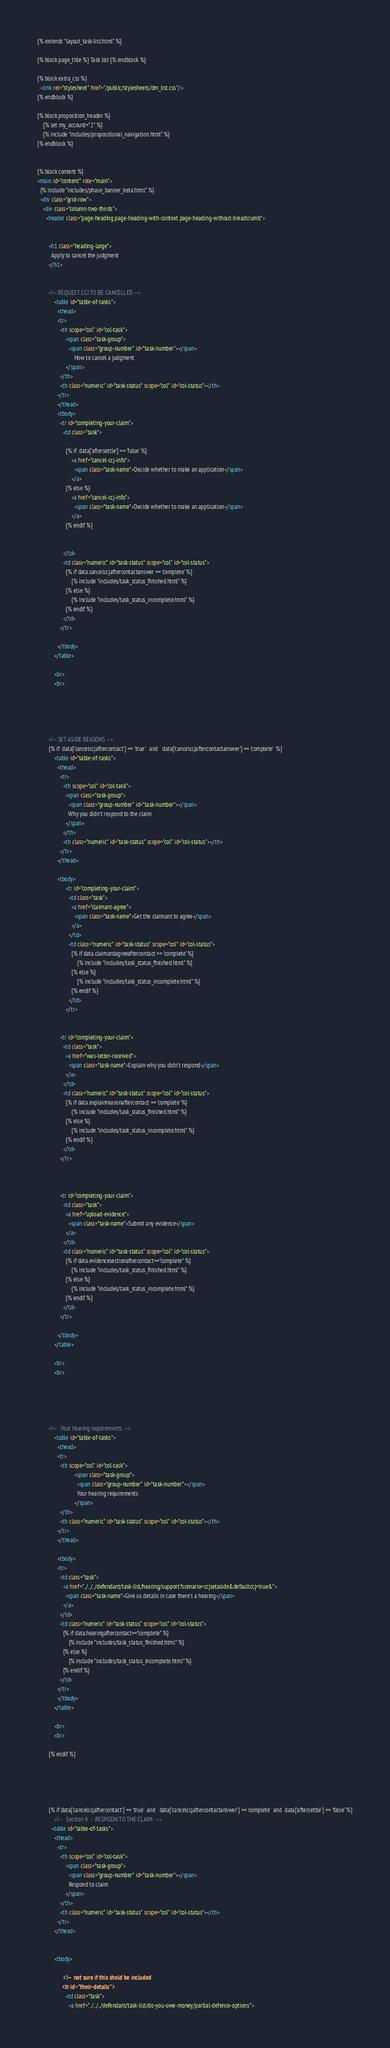Convert code to text. <code><loc_0><loc_0><loc_500><loc_500><_HTML_>{% extends "layout_task-list.html" %}

{% block page_title %} Task list {% endblock %}

{% block extra_css %}
  <link rel="stylesheet" href="/public/stylesheets/dm_list.css"/>
{% endblock %}

{% block proposition_header %}
    {% set my_account="2" %}
    {% include "includes/propositional_navigation.html" %}
{% endblock %}


{% block content %}
<main id="content" role="main">
  {% include "includes/phase_banner_beta.html" %}
  <div class="grid-row">
    <div class="column-two-thirds">
      <header class="page-heading page-heading-with-context page-heading-without-breadcrumb">


        <h1 class="heading-large">
          Apply to cancel the judgment
        </h1>


        <!-- REQUEST CCJ TO BE CANCELLED -->
            <table id="table-of-tasks">
              <thead>
              <tr>
                <th scope="col" id="col-task">
                    <span class="task-group">
                      <span class="group-number" id="task-number"></span>
                          How to cancel a judgment
                    </span>
                </th>
                <th class="numeric" id="task-status" scope="col" id="col-status"></th>
              </tr>
              </thead>
              <tbody>
                <tr id="completing-your-claim">
                  <td class="task">

                    {% if  data['aftersettle'] == 'false' %}
                        <a href="cancel-ccj-info">
                          <span class="task-name">Decide whether to make an application</span>
                        </a>
                    {% else %}
                        <a href="cancel-ccj-info">
                          <span class="task-name">Decide whether to make an application</span>
                        </a>
                    {% endif %}


                  </td>
                  <td class="numeric" id="task-status" scope="col" id="col-status">
                    {% if data.cancelccjaftercontactanswer == 'complete' %}
                        {% include "includes/task_status_finished.html" %}
                    {% else %}
                        {% include "includes/task_status_incomplete.html" %}
                    {% endif %}
                  </td>
                </tr>

              </tbody>
            </table>

            <br>
            <br>





        <!-- SET ASIDE REASONS -->
        {% if  data['cancelccjaftercontact'] == 'true'   and   data['cancelccjaftercontactanswer'] == 'complete'  %}
            <table id="table-of-tasks">
              <thead>
                <tr>
                  <th scope="col" id="col-task">
                    <span class="task-group">
                      <span class="group-number" id="task-number"></span>
                      Why you didn't respond to the claim
                    </span>
                  </th>
                  <th class="numeric" id="task-status" scope="col" id="col-status"></th>
                </tr>
              </thead>

              <tbody>
                    <tr id="completing-your-claim">
                      <td class="task">
                        <a href="claimant-agree">
                          <span class="task-name">Get the claimant to agree</span>
                        </a>
                      </td>
                      <td class="numeric" id="task-status" scope="col" id="col-status">
                        {% if data.claimantagreeaftercontact == 'complete' %}
                            {% include "includes/task_status_finished.html" %}
                        {% else %}
                            {% include "includes/task_status_incomplete.html" %}
                        {% endif %}
                      </td>
                    </tr>


                <tr id="completing-your-claim">
                  <td class="task">
                    <a href="was-letter-received">
                      <span class="task-name">Explain why you didn't respond</span>
                    </a>
                  </td>
                  <td class="numeric" id="task-status" scope="col" id="col-status">
                    {% if data.explainreasonaftercontact == 'complete' %}
                        {% include "includes/task_status_finished.html" %}
                    {% else %}
                        {% include "includes/task_status_incomplete.html" %}
                    {% endif %}
                  </td>
                </tr>



                <tr id="completing-your-claim">
                  <td class="task">
                    <a href="upload-evidence">
                      <span class="task-name">Submit any evidence</span>
                    </a>
                  </td>
                  <td class="numeric" id="task-status" scope="col" id="col-status">
                    {% if data.evidencesectionaftercontact=="complete" %}
                        {% include "includes/task_status_finished.html" %}
                    {% else %}
                        {% include "includes/task_status_incomplete.html" %}
                    {% endif %}
                  </td>
                </tr>

              </tbody>
            </table>

            <br>
            <br>





        <!--   Your hearing requirements  -->
            <table id="table-of-tasks">
              <thead>
              <tr>
                <th scope="col" id="col-task">
                          <span class="task-group">
                            <span class="group-number" id="task-number"></span>
                            Your hearing requirements
                          </span>
                </th>
                <th class="numeric" id="task-status" scope="col" id="col-status"></th>
              </tr>
              </thead>

              <tbody>
              <tr>
                <td class="task">
                  <a href="../../../defendant/task-list/hearing/support?scenario=ccjsetaside&defaultccj=true&">
                    <span class="task-name">Give us details in case there's a hearing</span>
                  </a>
                </td>
                <td class="numeric" id="task-status" scope="col" id="col-status">
                  {% if data.hearingaftercontact=="complete" %}
                      {% include "includes/task_status_finished.html" %}
                  {% else %}
                      {% include "includes/task_status_incomplete.html" %}
                  {% endif %}
                </td>
              </tr>
              </tbody>
            </table>

            <br>
            <br>

        {% endif %}





        {% if data['cancelccjaftercontact'] == 'true'  and   data['cancelccjaftercontactanswer'] == 'complete'  and  data['aftersettle'] == 'false' %}
            <!--   Section 4  -  RESPODN TO THE CLAIM  -->
          <table id="table-of-tasks">
            <thead>
              <tr>
                <th scope="col" id="col-task">
                    <span class="task-group">
                      <span class="group-number" id="task-number"></span>
                      Respond to claim
                    </span>
                </th>
                <th class="numeric" id="task-status" scope="col" id="col-status"></th>
              </tr>
            </thead>


            <tbody>

                  <!--  not sure if this shold be included
                  <tr id="their-details">
                    <td class="task">
                      <a href="../../../defendant/task-list/do-you-owe-money/partial-defence-options"></code> 